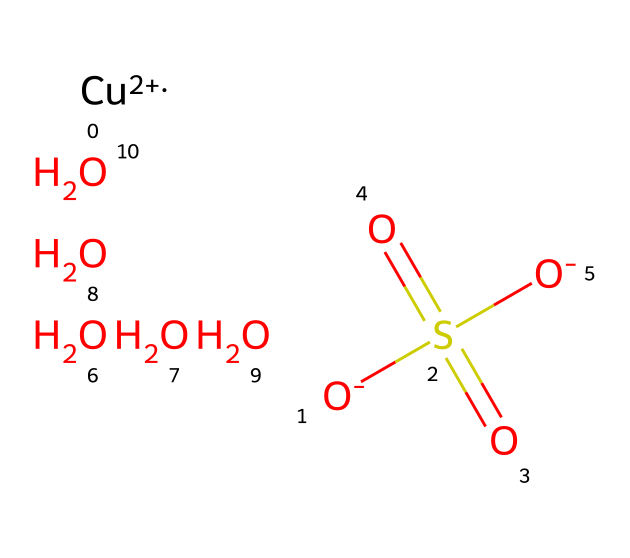What is the metal ion present in this fungicide? The SMILES representation indicates the presence of [Cu+2], which signifies that the metal ion in this compound is copper with a +2 oxidation state.
Answer: copper How many oxygen atoms are present in copper sulfate? By examining the SMILES notation, there are a total of five oxygen atoms indicated (four [O] and one in the sulfate group [=O]), which corresponds to its formula composition.
Answer: five What functional group is indicated by "S(=O)(=O)" in the structure? This part of the SMILES suggests that the sulfur is part of a sulfate group (SO4) due to the two double-bonded oxygens and one single-bonded oxygen, which is characteristic of sulfates.
Answer: sulfate What is the total charge of the copper ion in this structure? The notation [Cu+2] indicates that the copper ion has a +2 charge, which is explicitly shown in the SMILES, implying its oxidation state in this compound.
Answer: +2 Given the molecular composition, does this fungicide contain any acidic properties? The presence of the sulfate group (S(=O)(=O)O) implies that the compound can release hydrogen ions (H+) in solution, suggesting it has acidic properties typically associated with sulfuric acid-related compounds.
Answer: yes How does the inclusion of copper influence the sensory experiences related to this fungicide? Copper itself can have a sensory impact as it may lead to a metallic taste when present in substantial amounts; thus, it can affect the sensory experiences directly when inhaled or absorbed through the skin.
Answer: metallic taste What is the primary role of copper sulfate in gardening? Copper sulfate acts as a fungicide, which functions to inhibit fungal growth and protect plants from decay and diseases, reflecting its classification as a fungicide.
Answer: fungicide 